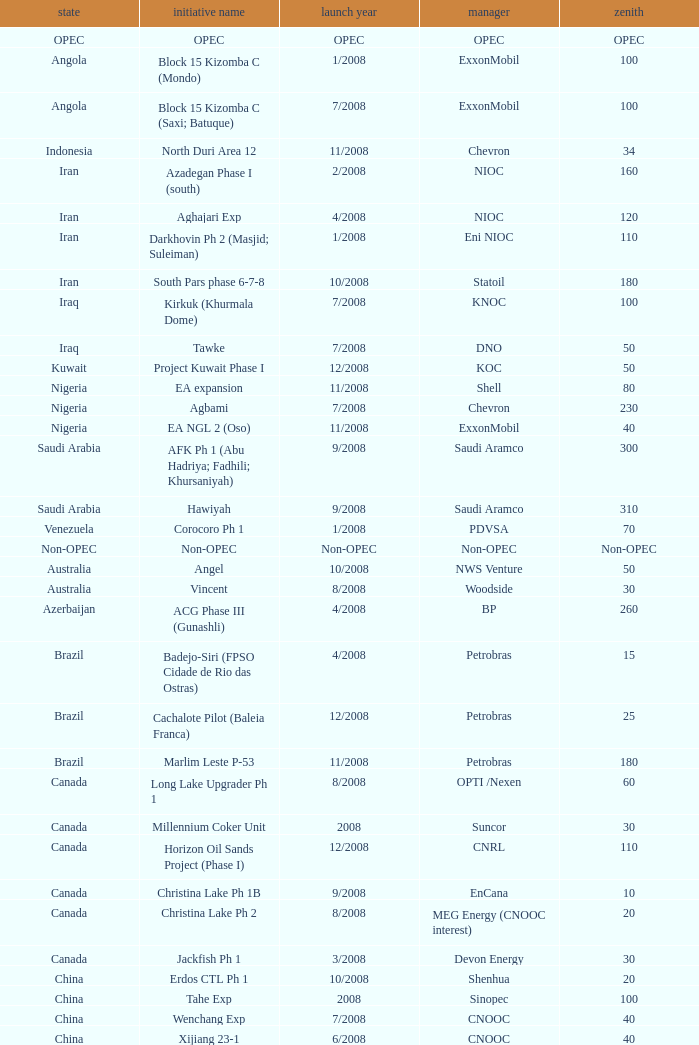What is the apex with a project name that is talakan ph 1? 60.0. 